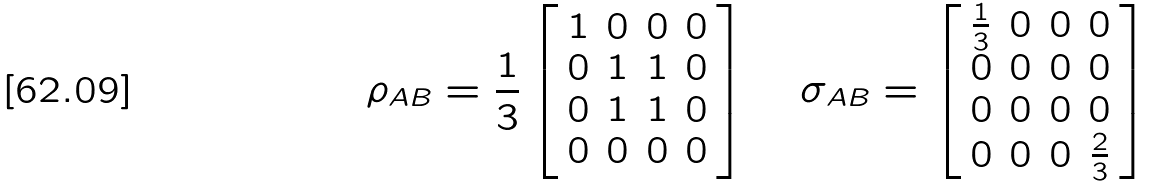<formula> <loc_0><loc_0><loc_500><loc_500>\rho _ { A B } = \frac { 1 } { 3 } \left [ \begin{array} { c c c c } 1 & 0 & 0 & 0 \\ 0 & 1 & 1 & 0 \\ 0 & 1 & 1 & 0 \\ 0 & 0 & 0 & 0 \end{array} \right ] \quad \sigma _ { A B } = \left [ \begin{array} { c c c c } \frac { 1 } { 3 } & 0 & 0 & 0 \\ 0 & 0 & 0 & 0 \\ 0 & 0 & 0 & 0 \\ 0 & 0 & 0 & \frac { 2 } { 3 } \end{array} \right ]</formula> 